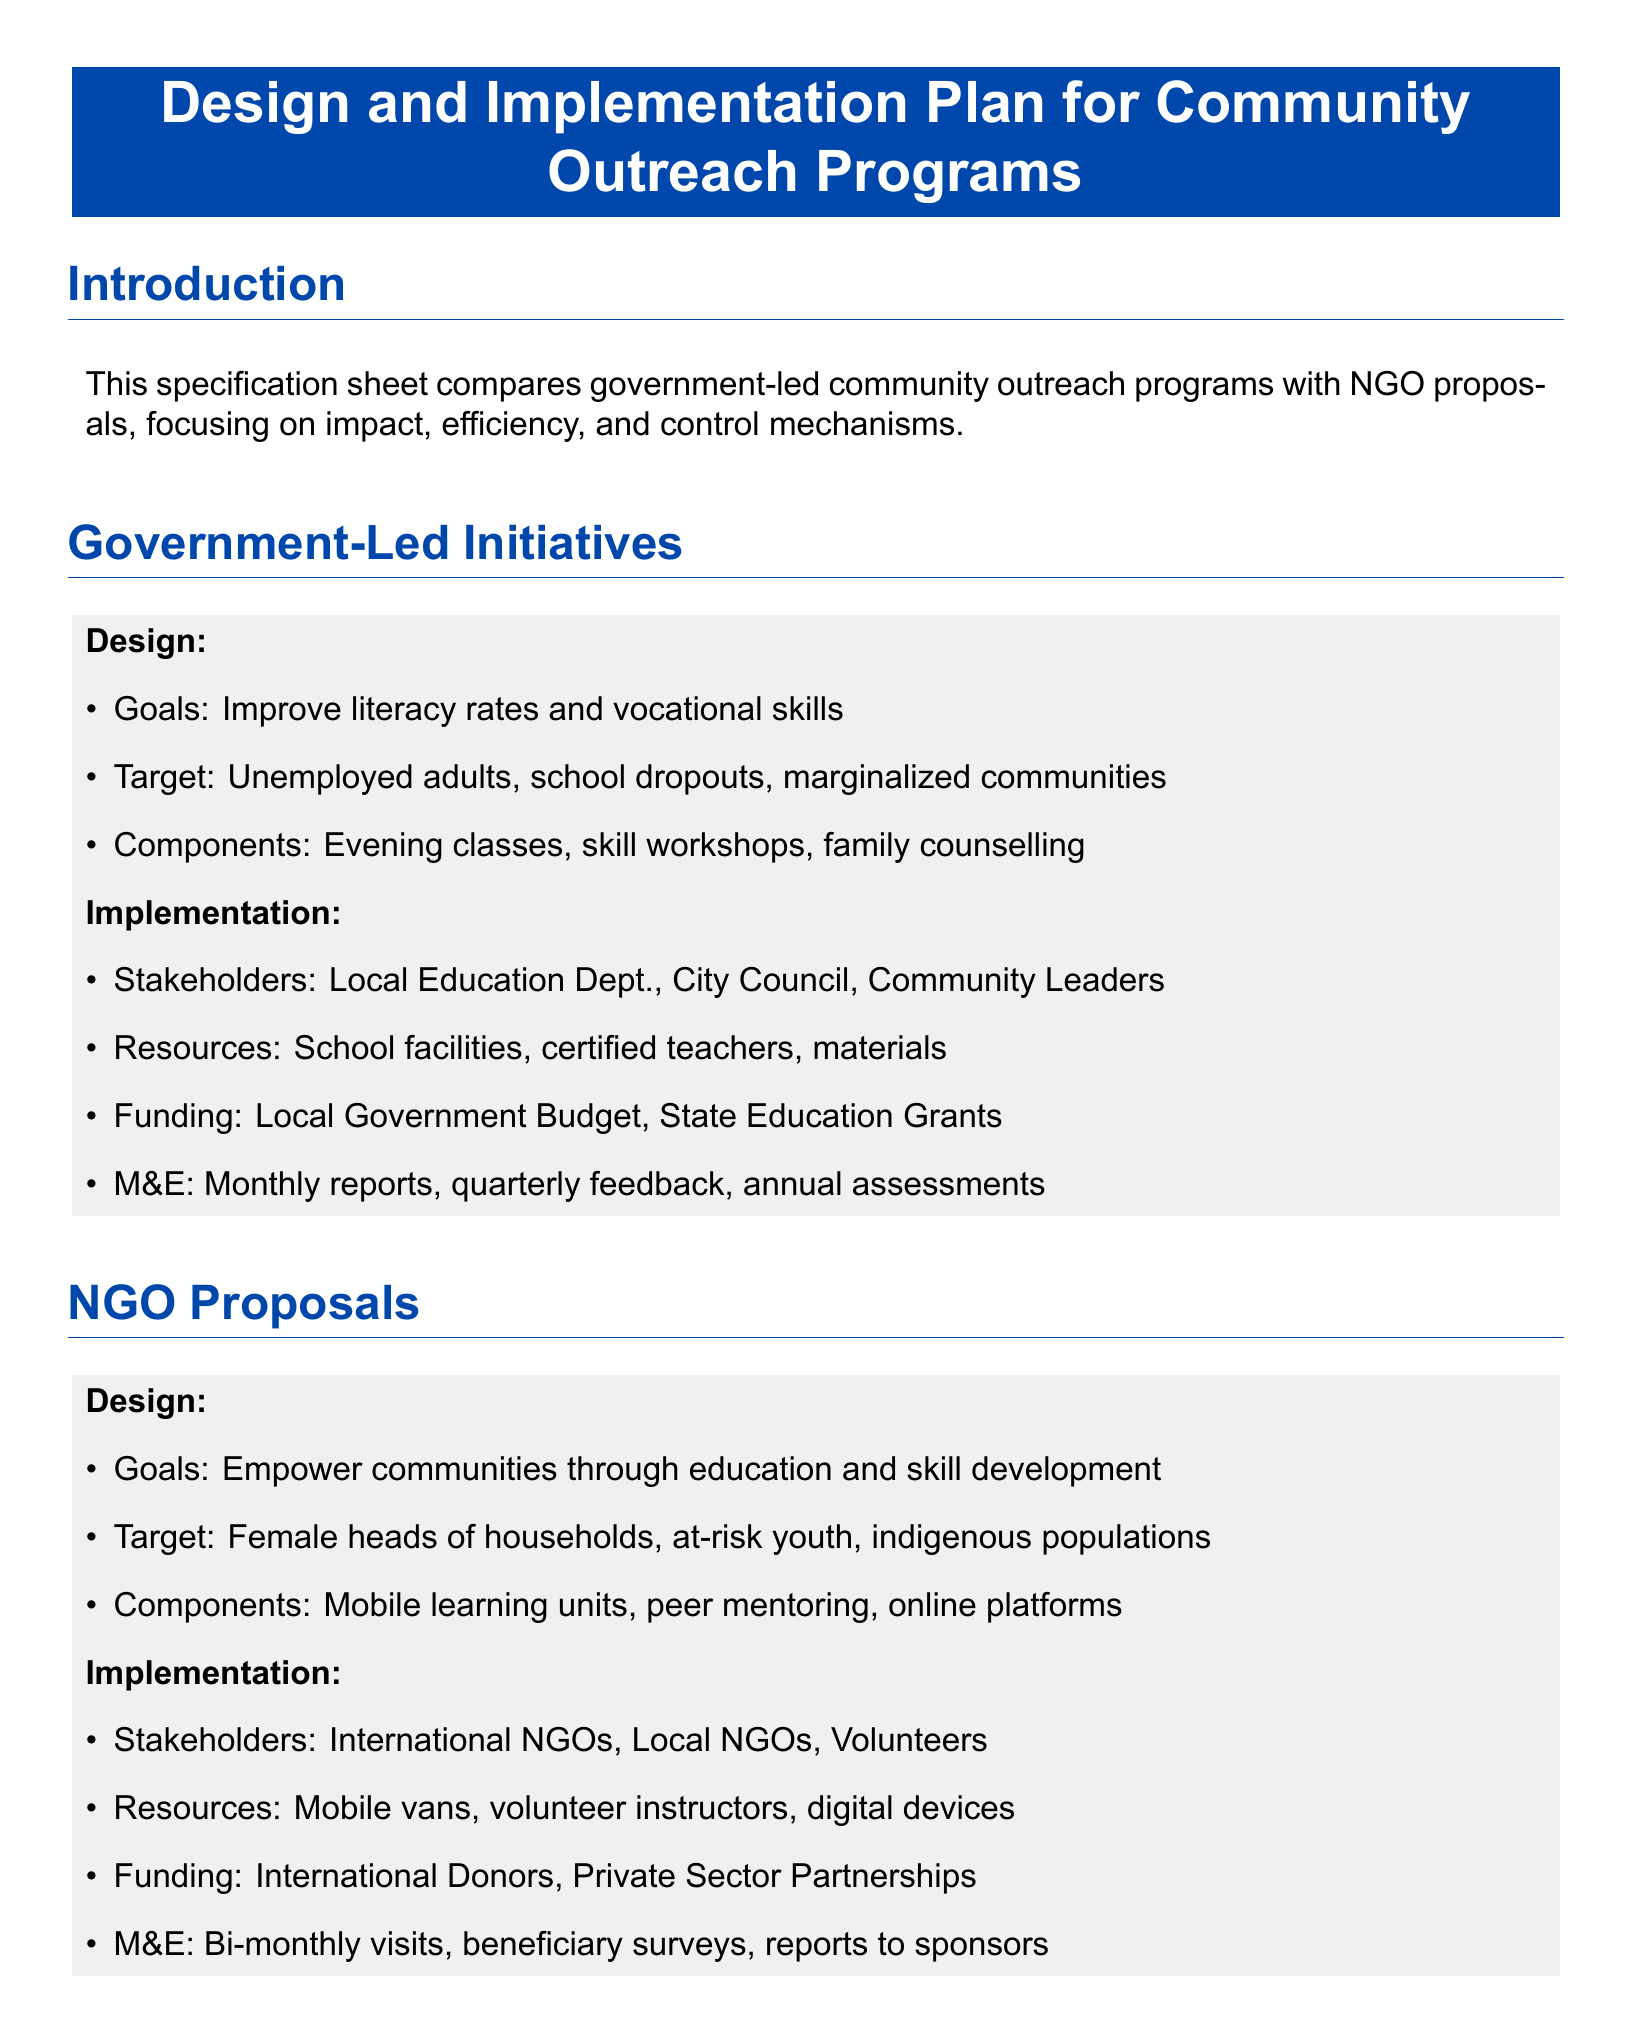What are the goals of government-led initiatives? The goals of government-led initiatives are to improve literacy rates and vocational skills.
Answer: Improve literacy rates and vocational skills Who are the target beneficiaries for NGO proposals? The target beneficiaries for NGO proposals are female heads of households, at-risk youth, and indigenous populations.
Answer: Female heads of households, at-risk youth, indigenous populations What resources do NGOs utilize in their proposals? NGOs utilize mobile vans, volunteer instructors, and digital devices as their resources.
Answer: Mobile vans, volunteer instructors, digital devices What is the funding source for government-led initiatives? The funding source for government-led initiatives comes from the local government budget and state education grants.
Answer: Local Government Budget, State Education Grants How do NGO proposals approach monitoring and evaluation? NGO proposals approach monitoring and evaluation by conducting bi-monthly visits, beneficiary surveys, and reports to sponsors.
Answer: Bi-monthly visits, beneficiary surveys, reports to sponsors Which model does the conclusion suggest for optimizing outcomes? The conclusion suggests a hybrid model leveraging governmental structure and NGO innovation to optimize outcomes.
Answer: Hybrid model What component is part of the design for government-led initiatives? A component that is part of the design for government-led initiatives is evening classes.
Answer: Evening classes What is a key difference in control between government and NGO proposals? A key difference in control is that government proposals are centralized while NGOs have a decentralized approach.
Answer: Centralized, decentralized 